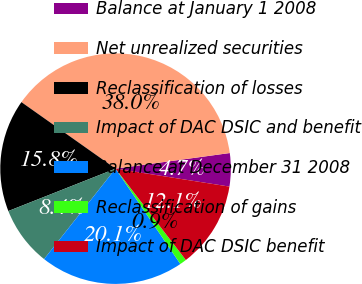<chart> <loc_0><loc_0><loc_500><loc_500><pie_chart><fcel>Balance at January 1 2008<fcel>Net unrealized securities<fcel>Reclassification of losses<fcel>Impact of DAC DSIC and benefit<fcel>Balance at December 31 2008<fcel>Reclassification of gains<fcel>Impact of DAC DSIC benefit<nl><fcel>4.65%<fcel>38.04%<fcel>15.78%<fcel>8.36%<fcel>20.14%<fcel>0.94%<fcel>12.07%<nl></chart> 